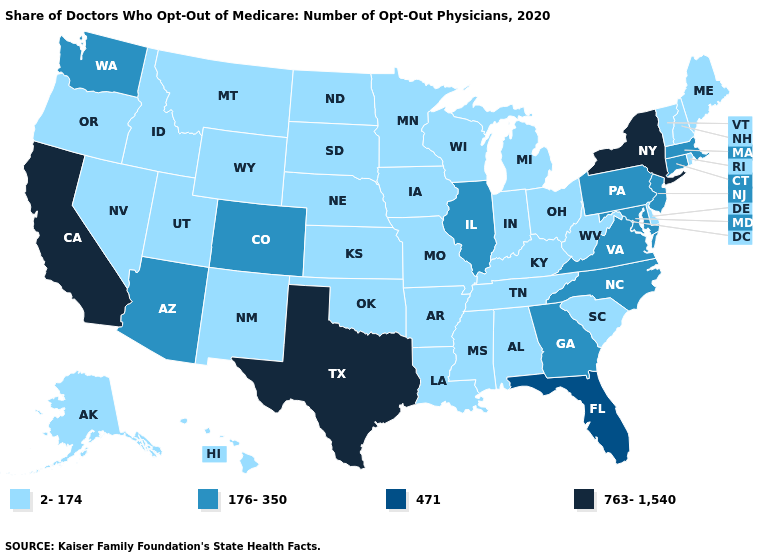Name the states that have a value in the range 176-350?
Be succinct. Arizona, Colorado, Connecticut, Georgia, Illinois, Maryland, Massachusetts, New Jersey, North Carolina, Pennsylvania, Virginia, Washington. What is the highest value in the Northeast ?
Quick response, please. 763-1,540. Name the states that have a value in the range 471?
Quick response, please. Florida. Name the states that have a value in the range 763-1,540?
Answer briefly. California, New York, Texas. What is the lowest value in the USA?
Be succinct. 2-174. What is the value of North Dakota?
Quick response, please. 2-174. What is the highest value in the USA?
Keep it brief. 763-1,540. What is the value of Oklahoma?
Quick response, please. 2-174. Name the states that have a value in the range 2-174?
Concise answer only. Alabama, Alaska, Arkansas, Delaware, Hawaii, Idaho, Indiana, Iowa, Kansas, Kentucky, Louisiana, Maine, Michigan, Minnesota, Mississippi, Missouri, Montana, Nebraska, Nevada, New Hampshire, New Mexico, North Dakota, Ohio, Oklahoma, Oregon, Rhode Island, South Carolina, South Dakota, Tennessee, Utah, Vermont, West Virginia, Wisconsin, Wyoming. Name the states that have a value in the range 2-174?
Answer briefly. Alabama, Alaska, Arkansas, Delaware, Hawaii, Idaho, Indiana, Iowa, Kansas, Kentucky, Louisiana, Maine, Michigan, Minnesota, Mississippi, Missouri, Montana, Nebraska, Nevada, New Hampshire, New Mexico, North Dakota, Ohio, Oklahoma, Oregon, Rhode Island, South Carolina, South Dakota, Tennessee, Utah, Vermont, West Virginia, Wisconsin, Wyoming. Among the states that border Washington , which have the highest value?
Concise answer only. Idaho, Oregon. Among the states that border Utah , which have the lowest value?
Keep it brief. Idaho, Nevada, New Mexico, Wyoming. Name the states that have a value in the range 2-174?
Keep it brief. Alabama, Alaska, Arkansas, Delaware, Hawaii, Idaho, Indiana, Iowa, Kansas, Kentucky, Louisiana, Maine, Michigan, Minnesota, Mississippi, Missouri, Montana, Nebraska, Nevada, New Hampshire, New Mexico, North Dakota, Ohio, Oklahoma, Oregon, Rhode Island, South Carolina, South Dakota, Tennessee, Utah, Vermont, West Virginia, Wisconsin, Wyoming. Name the states that have a value in the range 763-1,540?
Keep it brief. California, New York, Texas. 